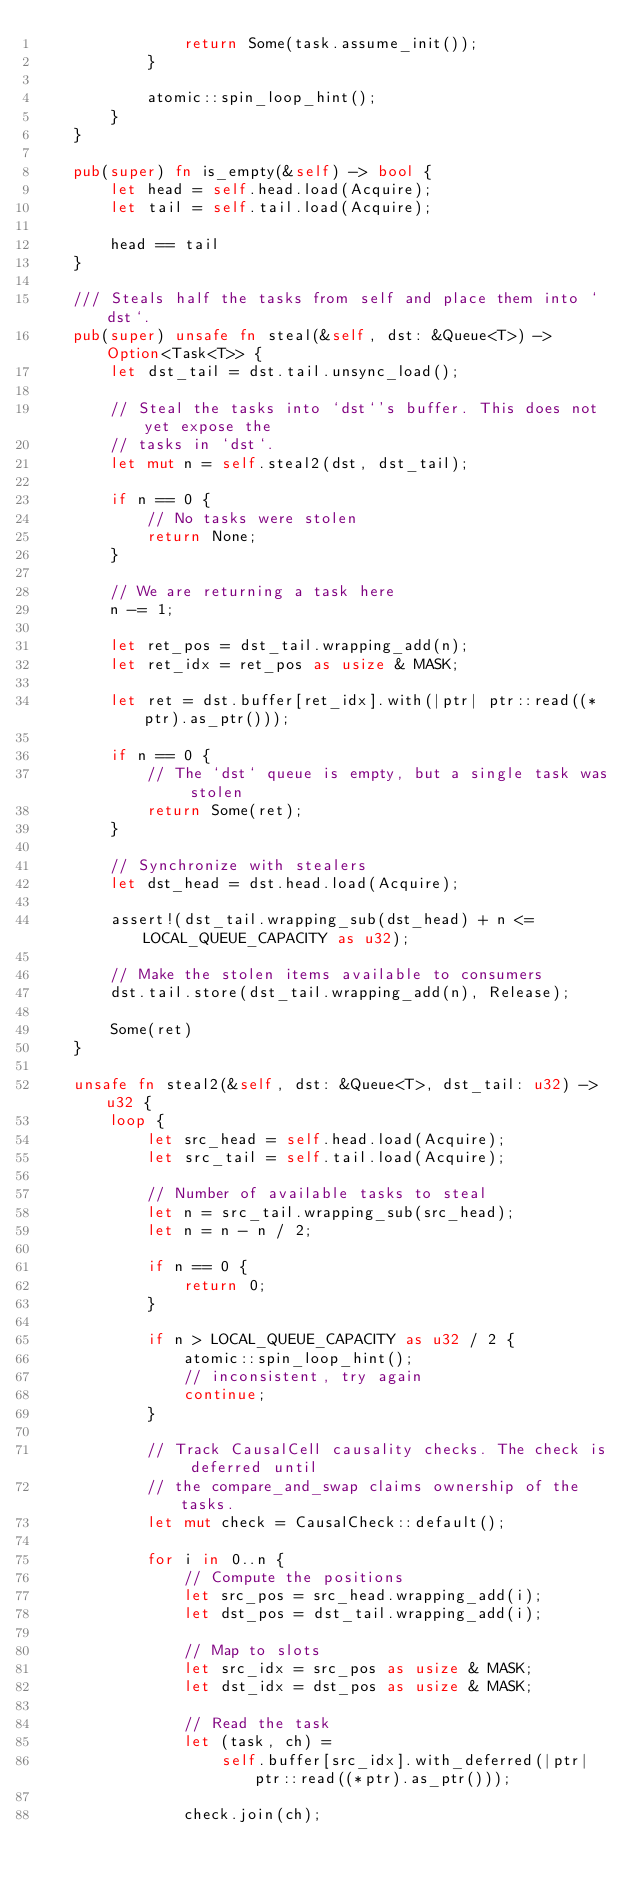<code> <loc_0><loc_0><loc_500><loc_500><_Rust_>                return Some(task.assume_init());
            }

            atomic::spin_loop_hint();
        }
    }

    pub(super) fn is_empty(&self) -> bool {
        let head = self.head.load(Acquire);
        let tail = self.tail.load(Acquire);

        head == tail
    }

    /// Steals half the tasks from self and place them into `dst`.
    pub(super) unsafe fn steal(&self, dst: &Queue<T>) -> Option<Task<T>> {
        let dst_tail = dst.tail.unsync_load();

        // Steal the tasks into `dst`'s buffer. This does not yet expose the
        // tasks in `dst`.
        let mut n = self.steal2(dst, dst_tail);

        if n == 0 {
            // No tasks were stolen
            return None;
        }

        // We are returning a task here
        n -= 1;

        let ret_pos = dst_tail.wrapping_add(n);
        let ret_idx = ret_pos as usize & MASK;

        let ret = dst.buffer[ret_idx].with(|ptr| ptr::read((*ptr).as_ptr()));

        if n == 0 {
            // The `dst` queue is empty, but a single task was stolen
            return Some(ret);
        }

        // Synchronize with stealers
        let dst_head = dst.head.load(Acquire);

        assert!(dst_tail.wrapping_sub(dst_head) + n <= LOCAL_QUEUE_CAPACITY as u32);

        // Make the stolen items available to consumers
        dst.tail.store(dst_tail.wrapping_add(n), Release);

        Some(ret)
    }

    unsafe fn steal2(&self, dst: &Queue<T>, dst_tail: u32) -> u32 {
        loop {
            let src_head = self.head.load(Acquire);
            let src_tail = self.tail.load(Acquire);

            // Number of available tasks to steal
            let n = src_tail.wrapping_sub(src_head);
            let n = n - n / 2;

            if n == 0 {
                return 0;
            }

            if n > LOCAL_QUEUE_CAPACITY as u32 / 2 {
                atomic::spin_loop_hint();
                // inconsistent, try again
                continue;
            }

            // Track CausalCell causality checks. The check is deferred until
            // the compare_and_swap claims ownership of the tasks.
            let mut check = CausalCheck::default();

            for i in 0..n {
                // Compute the positions
                let src_pos = src_head.wrapping_add(i);
                let dst_pos = dst_tail.wrapping_add(i);

                // Map to slots
                let src_idx = src_pos as usize & MASK;
                let dst_idx = dst_pos as usize & MASK;

                // Read the task
                let (task, ch) =
                    self.buffer[src_idx].with_deferred(|ptr| ptr::read((*ptr).as_ptr()));

                check.join(ch);
</code> 